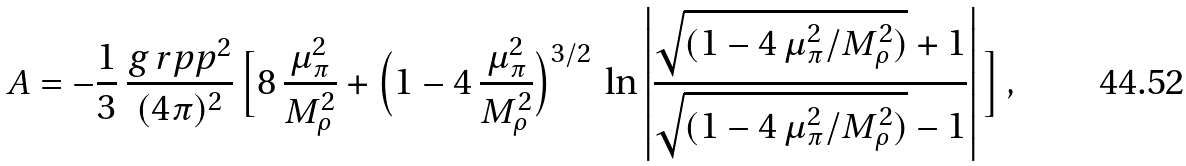<formula> <loc_0><loc_0><loc_500><loc_500>A = - \frac { 1 } { 3 } \, \frac { g _ { \ } r p p ^ { 2 } } { ( 4 \pi ) ^ { 2 } } \, \Big { [ } 8 \, \frac { \mu _ { \pi } ^ { 2 } } { M _ { \rho } ^ { 2 } } + \Big { ( } 1 - 4 \, \frac { \mu _ { \pi } ^ { 2 } } { M _ { \rho } ^ { 2 } } \Big { ) } ^ { 3 / 2 } \, \ln \left | \frac { \sqrt { ( 1 - 4 \, \mu _ { \pi } ^ { 2 } / M _ { \rho } ^ { 2 } ) } + 1 } { \sqrt { ( 1 - 4 \, \mu _ { \pi } ^ { 2 } / M _ { \rho } ^ { 2 } ) } - 1 } \right | \Big { ] } \, ,</formula> 